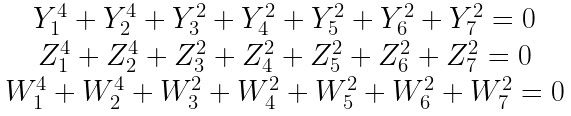Convert formula to latex. <formula><loc_0><loc_0><loc_500><loc_500>\begin{matrix} Y _ { 1 } ^ { 4 } + Y _ { 2 } ^ { 4 } + Y _ { 3 } ^ { 2 } + Y _ { 4 } ^ { 2 } + Y _ { 5 } ^ { 2 } + Y _ { 6 } ^ { 2 } + Y _ { 7 } ^ { 2 } = 0 \\ Z _ { 1 } ^ { 4 } + Z _ { 2 } ^ { 4 } + Z _ { 3 } ^ { 2 } + Z _ { 4 } ^ { 2 } + Z _ { 5 } ^ { 2 } + Z _ { 6 } ^ { 2 } + Z _ { 7 } ^ { 2 } = 0 \\ W _ { 1 } ^ { 4 } + W _ { 2 } ^ { 4 } + W _ { 3 } ^ { 2 } + W _ { 4 } ^ { 2 } + W _ { 5 } ^ { 2 } + W _ { 6 } ^ { 2 } + W _ { 7 } ^ { 2 } = 0 \end{matrix}</formula> 